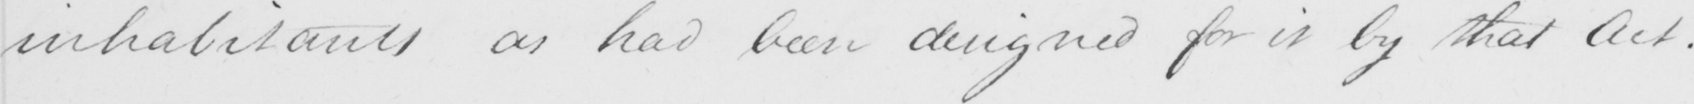What is written in this line of handwriting? inhabitants as had been designed for it by that Act . 